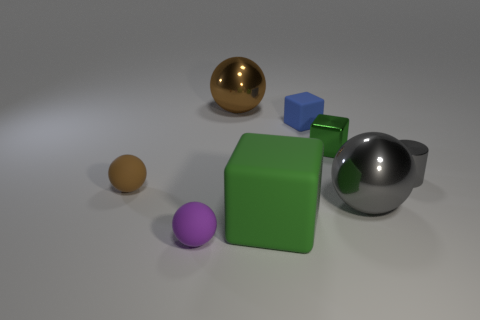Can you describe the lighting and shadows in the image, and what they suggest about the light source? The image features a uniform lighting with soft shadows that extend to the right of the objects, indicating that the light source is located to the left of the scene. The diffuse nature of the shadows suggests a not overly harsh or direct light source, creating a calm and even illumination without sharp contrasts. 